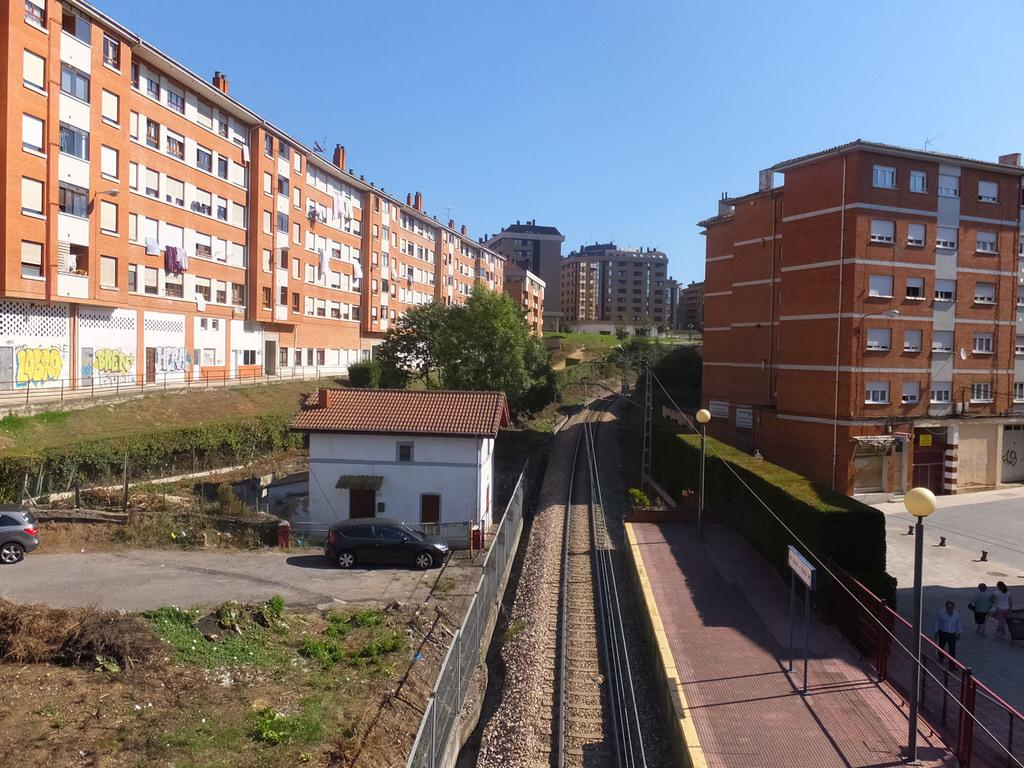What can be seen in the sky in the image? The sky is visible in the image. What type of structures are present in the image? There are buildings in the image. What type of barriers can be seen in the image? There are fences in the image. What type of vegetation is present in the image? Trees are present in the image. What type of surface is visible in the image? The ground is visible in the image. What type of transportation is on the road in the image? Motor vehicles are on the road in the image. What type of transportation infrastructure is present in the image? There is a railway track in the image. What type of vertical structures are present in the image? Street poles are present in the image. What type of lighting is visible in the image? Street lights are visible in the image. What type of activity can be seen involving people in the image? Persons are walking on the road in the image. Can you read the caption on the goat in the image? There is no goat present in the image, and therefore no caption to read. What type of blade is being used by the person walking on the road in the image? There is no blade visible in the image, and no person is using one. 